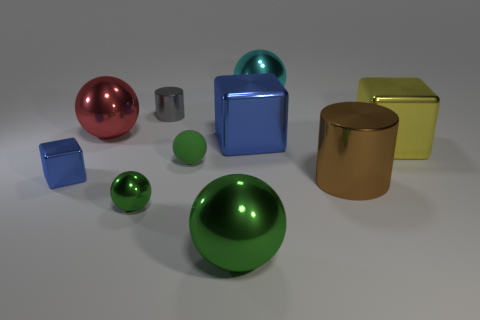Subtract all big green balls. How many balls are left? 4 Subtract all brown balls. How many blue cubes are left? 2 Subtract all green spheres. How many spheres are left? 2 Subtract 2 cylinders. How many cylinders are left? 0 Subtract all cylinders. How many objects are left? 8 Subtract 0 purple cubes. How many objects are left? 10 Subtract all green cubes. Subtract all purple balls. How many cubes are left? 3 Subtract all cyan metal things. Subtract all metallic objects. How many objects are left? 0 Add 7 big shiny blocks. How many big shiny blocks are left? 9 Add 6 big red metallic balls. How many big red metallic balls exist? 7 